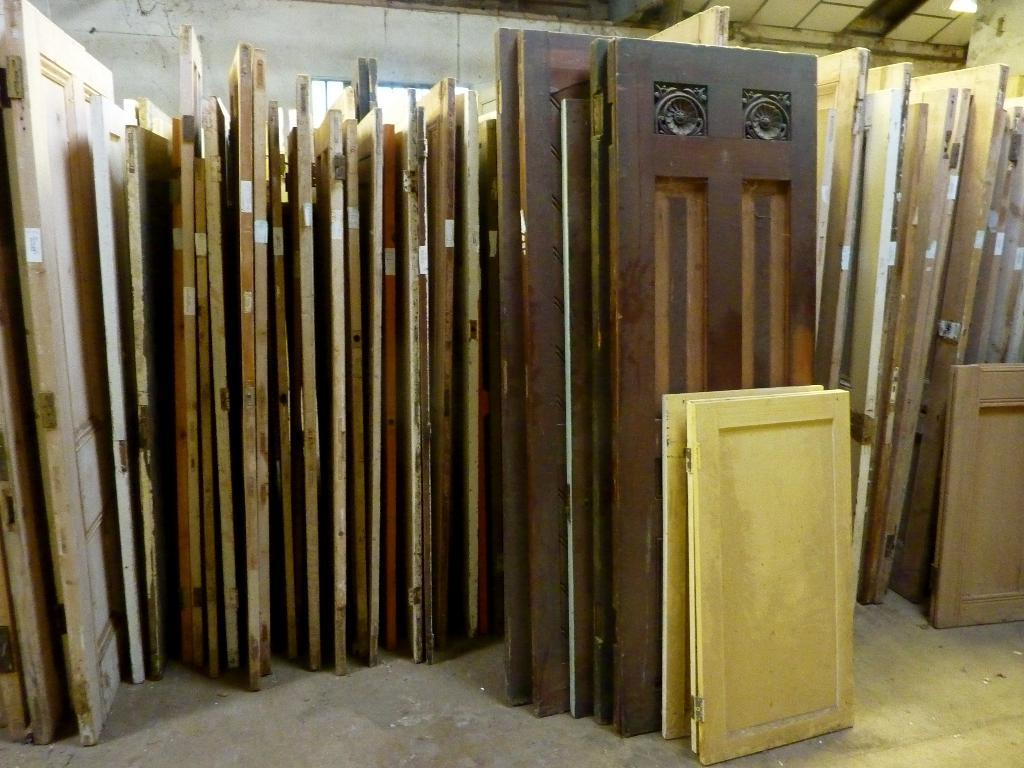What type of doors are in the center of the image? There are wooden doors in the center of the image. What surface can be seen underfoot in the image? There is a floor visible in the image. What is located behind the doors in the image? There is a wall in the background of the image. What can be seen through the wall in the image? There are windows in the background of the image. What is above the doors in the image? There is a ceiling visible at the top of the image. What type of ground can be seen through the windows in the image? There is no ground visible through the windows in the image; only the windows and the wall behind them can be seen. 